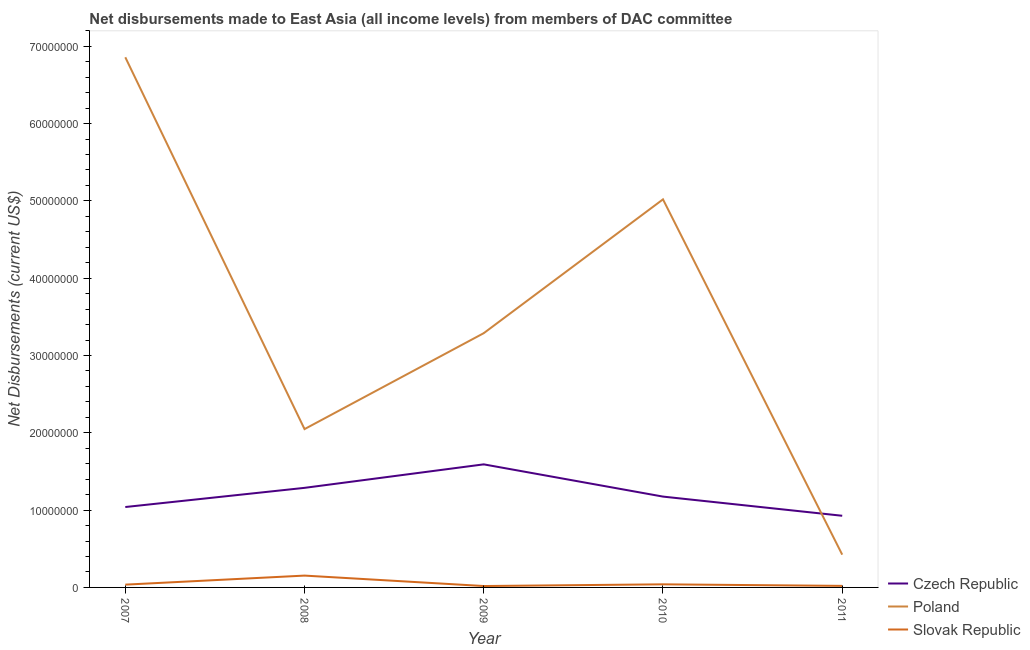How many different coloured lines are there?
Offer a very short reply. 3. Does the line corresponding to net disbursements made by slovak republic intersect with the line corresponding to net disbursements made by czech republic?
Offer a terse response. No. What is the net disbursements made by slovak republic in 2011?
Your response must be concise. 2.00e+05. Across all years, what is the maximum net disbursements made by poland?
Your response must be concise. 6.86e+07. Across all years, what is the minimum net disbursements made by czech republic?
Offer a terse response. 9.27e+06. In which year was the net disbursements made by poland minimum?
Provide a succinct answer. 2011. What is the total net disbursements made by czech republic in the graph?
Your answer should be very brief. 6.02e+07. What is the difference between the net disbursements made by slovak republic in 2007 and that in 2011?
Give a very brief answer. 1.60e+05. What is the difference between the net disbursements made by czech republic in 2007 and the net disbursements made by slovak republic in 2008?
Give a very brief answer. 8.87e+06. What is the average net disbursements made by slovak republic per year?
Provide a succinct answer. 5.34e+05. In the year 2010, what is the difference between the net disbursements made by czech republic and net disbursements made by poland?
Offer a terse response. -3.84e+07. In how many years, is the net disbursements made by poland greater than 66000000 US$?
Offer a very short reply. 1. What is the ratio of the net disbursements made by czech republic in 2007 to that in 2011?
Provide a short and direct response. 1.12. Is the difference between the net disbursements made by poland in 2007 and 2011 greater than the difference between the net disbursements made by slovak republic in 2007 and 2011?
Offer a very short reply. Yes. What is the difference between the highest and the second highest net disbursements made by slovak republic?
Offer a very short reply. 1.13e+06. What is the difference between the highest and the lowest net disbursements made by czech republic?
Offer a terse response. 6.65e+06. In how many years, is the net disbursements made by czech republic greater than the average net disbursements made by czech republic taken over all years?
Your response must be concise. 2. Is the sum of the net disbursements made by czech republic in 2007 and 2011 greater than the maximum net disbursements made by slovak republic across all years?
Provide a succinct answer. Yes. Is it the case that in every year, the sum of the net disbursements made by czech republic and net disbursements made by poland is greater than the net disbursements made by slovak republic?
Provide a short and direct response. Yes. Does the net disbursements made by slovak republic monotonically increase over the years?
Your response must be concise. No. Is the net disbursements made by poland strictly greater than the net disbursements made by slovak republic over the years?
Offer a very short reply. Yes. What is the difference between two consecutive major ticks on the Y-axis?
Give a very brief answer. 1.00e+07. Does the graph contain any zero values?
Ensure brevity in your answer.  No. Does the graph contain grids?
Offer a terse response. No. How many legend labels are there?
Your answer should be very brief. 3. What is the title of the graph?
Make the answer very short. Net disbursements made to East Asia (all income levels) from members of DAC committee. Does "Wage workers" appear as one of the legend labels in the graph?
Offer a terse response. No. What is the label or title of the Y-axis?
Keep it short and to the point. Net Disbursements (current US$). What is the Net Disbursements (current US$) of Czech Republic in 2007?
Keep it short and to the point. 1.04e+07. What is the Net Disbursements (current US$) in Poland in 2007?
Give a very brief answer. 6.86e+07. What is the Net Disbursements (current US$) of Czech Republic in 2008?
Your answer should be compact. 1.29e+07. What is the Net Disbursements (current US$) of Poland in 2008?
Provide a short and direct response. 2.05e+07. What is the Net Disbursements (current US$) in Slovak Republic in 2008?
Ensure brevity in your answer.  1.53e+06. What is the Net Disbursements (current US$) in Czech Republic in 2009?
Offer a very short reply. 1.59e+07. What is the Net Disbursements (current US$) in Poland in 2009?
Give a very brief answer. 3.29e+07. What is the Net Disbursements (current US$) in Czech Republic in 2010?
Ensure brevity in your answer.  1.18e+07. What is the Net Disbursements (current US$) in Poland in 2010?
Offer a very short reply. 5.02e+07. What is the Net Disbursements (current US$) in Slovak Republic in 2010?
Provide a short and direct response. 4.00e+05. What is the Net Disbursements (current US$) in Czech Republic in 2011?
Offer a terse response. 9.27e+06. What is the Net Disbursements (current US$) in Poland in 2011?
Keep it short and to the point. 4.24e+06. What is the Net Disbursements (current US$) in Slovak Republic in 2011?
Your response must be concise. 2.00e+05. Across all years, what is the maximum Net Disbursements (current US$) of Czech Republic?
Offer a terse response. 1.59e+07. Across all years, what is the maximum Net Disbursements (current US$) of Poland?
Ensure brevity in your answer.  6.86e+07. Across all years, what is the maximum Net Disbursements (current US$) of Slovak Republic?
Give a very brief answer. 1.53e+06. Across all years, what is the minimum Net Disbursements (current US$) of Czech Republic?
Give a very brief answer. 9.27e+06. Across all years, what is the minimum Net Disbursements (current US$) in Poland?
Your answer should be very brief. 4.24e+06. What is the total Net Disbursements (current US$) in Czech Republic in the graph?
Your response must be concise. 6.02e+07. What is the total Net Disbursements (current US$) in Poland in the graph?
Your answer should be very brief. 1.76e+08. What is the total Net Disbursements (current US$) of Slovak Republic in the graph?
Ensure brevity in your answer.  2.67e+06. What is the difference between the Net Disbursements (current US$) of Czech Republic in 2007 and that in 2008?
Offer a very short reply. -2.48e+06. What is the difference between the Net Disbursements (current US$) in Poland in 2007 and that in 2008?
Keep it short and to the point. 4.81e+07. What is the difference between the Net Disbursements (current US$) in Slovak Republic in 2007 and that in 2008?
Your answer should be compact. -1.17e+06. What is the difference between the Net Disbursements (current US$) in Czech Republic in 2007 and that in 2009?
Give a very brief answer. -5.52e+06. What is the difference between the Net Disbursements (current US$) in Poland in 2007 and that in 2009?
Make the answer very short. 3.57e+07. What is the difference between the Net Disbursements (current US$) in Czech Republic in 2007 and that in 2010?
Keep it short and to the point. -1.35e+06. What is the difference between the Net Disbursements (current US$) in Poland in 2007 and that in 2010?
Offer a very short reply. 1.84e+07. What is the difference between the Net Disbursements (current US$) of Czech Republic in 2007 and that in 2011?
Your answer should be very brief. 1.13e+06. What is the difference between the Net Disbursements (current US$) of Poland in 2007 and that in 2011?
Ensure brevity in your answer.  6.43e+07. What is the difference between the Net Disbursements (current US$) of Slovak Republic in 2007 and that in 2011?
Give a very brief answer. 1.60e+05. What is the difference between the Net Disbursements (current US$) of Czech Republic in 2008 and that in 2009?
Make the answer very short. -3.04e+06. What is the difference between the Net Disbursements (current US$) in Poland in 2008 and that in 2009?
Make the answer very short. -1.24e+07. What is the difference between the Net Disbursements (current US$) of Slovak Republic in 2008 and that in 2009?
Your answer should be compact. 1.35e+06. What is the difference between the Net Disbursements (current US$) of Czech Republic in 2008 and that in 2010?
Give a very brief answer. 1.13e+06. What is the difference between the Net Disbursements (current US$) in Poland in 2008 and that in 2010?
Your answer should be very brief. -2.97e+07. What is the difference between the Net Disbursements (current US$) in Slovak Republic in 2008 and that in 2010?
Make the answer very short. 1.13e+06. What is the difference between the Net Disbursements (current US$) of Czech Republic in 2008 and that in 2011?
Make the answer very short. 3.61e+06. What is the difference between the Net Disbursements (current US$) in Poland in 2008 and that in 2011?
Make the answer very short. 1.62e+07. What is the difference between the Net Disbursements (current US$) in Slovak Republic in 2008 and that in 2011?
Keep it short and to the point. 1.33e+06. What is the difference between the Net Disbursements (current US$) of Czech Republic in 2009 and that in 2010?
Keep it short and to the point. 4.17e+06. What is the difference between the Net Disbursements (current US$) in Poland in 2009 and that in 2010?
Give a very brief answer. -1.73e+07. What is the difference between the Net Disbursements (current US$) in Slovak Republic in 2009 and that in 2010?
Your response must be concise. -2.20e+05. What is the difference between the Net Disbursements (current US$) of Czech Republic in 2009 and that in 2011?
Your answer should be very brief. 6.65e+06. What is the difference between the Net Disbursements (current US$) of Poland in 2009 and that in 2011?
Give a very brief answer. 2.86e+07. What is the difference between the Net Disbursements (current US$) in Slovak Republic in 2009 and that in 2011?
Ensure brevity in your answer.  -2.00e+04. What is the difference between the Net Disbursements (current US$) of Czech Republic in 2010 and that in 2011?
Ensure brevity in your answer.  2.48e+06. What is the difference between the Net Disbursements (current US$) in Poland in 2010 and that in 2011?
Give a very brief answer. 4.60e+07. What is the difference between the Net Disbursements (current US$) of Czech Republic in 2007 and the Net Disbursements (current US$) of Poland in 2008?
Give a very brief answer. -1.01e+07. What is the difference between the Net Disbursements (current US$) in Czech Republic in 2007 and the Net Disbursements (current US$) in Slovak Republic in 2008?
Your answer should be very brief. 8.87e+06. What is the difference between the Net Disbursements (current US$) of Poland in 2007 and the Net Disbursements (current US$) of Slovak Republic in 2008?
Your response must be concise. 6.70e+07. What is the difference between the Net Disbursements (current US$) in Czech Republic in 2007 and the Net Disbursements (current US$) in Poland in 2009?
Offer a very short reply. -2.25e+07. What is the difference between the Net Disbursements (current US$) in Czech Republic in 2007 and the Net Disbursements (current US$) in Slovak Republic in 2009?
Your answer should be compact. 1.02e+07. What is the difference between the Net Disbursements (current US$) in Poland in 2007 and the Net Disbursements (current US$) in Slovak Republic in 2009?
Your answer should be very brief. 6.84e+07. What is the difference between the Net Disbursements (current US$) in Czech Republic in 2007 and the Net Disbursements (current US$) in Poland in 2010?
Make the answer very short. -3.98e+07. What is the difference between the Net Disbursements (current US$) in Poland in 2007 and the Net Disbursements (current US$) in Slovak Republic in 2010?
Keep it short and to the point. 6.82e+07. What is the difference between the Net Disbursements (current US$) in Czech Republic in 2007 and the Net Disbursements (current US$) in Poland in 2011?
Give a very brief answer. 6.16e+06. What is the difference between the Net Disbursements (current US$) in Czech Republic in 2007 and the Net Disbursements (current US$) in Slovak Republic in 2011?
Your answer should be very brief. 1.02e+07. What is the difference between the Net Disbursements (current US$) of Poland in 2007 and the Net Disbursements (current US$) of Slovak Republic in 2011?
Make the answer very short. 6.84e+07. What is the difference between the Net Disbursements (current US$) of Czech Republic in 2008 and the Net Disbursements (current US$) of Poland in 2009?
Provide a short and direct response. -2.00e+07. What is the difference between the Net Disbursements (current US$) of Czech Republic in 2008 and the Net Disbursements (current US$) of Slovak Republic in 2009?
Offer a very short reply. 1.27e+07. What is the difference between the Net Disbursements (current US$) of Poland in 2008 and the Net Disbursements (current US$) of Slovak Republic in 2009?
Your answer should be compact. 2.03e+07. What is the difference between the Net Disbursements (current US$) of Czech Republic in 2008 and the Net Disbursements (current US$) of Poland in 2010?
Keep it short and to the point. -3.73e+07. What is the difference between the Net Disbursements (current US$) of Czech Republic in 2008 and the Net Disbursements (current US$) of Slovak Republic in 2010?
Ensure brevity in your answer.  1.25e+07. What is the difference between the Net Disbursements (current US$) of Poland in 2008 and the Net Disbursements (current US$) of Slovak Republic in 2010?
Your response must be concise. 2.01e+07. What is the difference between the Net Disbursements (current US$) of Czech Republic in 2008 and the Net Disbursements (current US$) of Poland in 2011?
Your answer should be very brief. 8.64e+06. What is the difference between the Net Disbursements (current US$) of Czech Republic in 2008 and the Net Disbursements (current US$) of Slovak Republic in 2011?
Your answer should be compact. 1.27e+07. What is the difference between the Net Disbursements (current US$) of Poland in 2008 and the Net Disbursements (current US$) of Slovak Republic in 2011?
Offer a very short reply. 2.03e+07. What is the difference between the Net Disbursements (current US$) of Czech Republic in 2009 and the Net Disbursements (current US$) of Poland in 2010?
Keep it short and to the point. -3.43e+07. What is the difference between the Net Disbursements (current US$) in Czech Republic in 2009 and the Net Disbursements (current US$) in Slovak Republic in 2010?
Your response must be concise. 1.55e+07. What is the difference between the Net Disbursements (current US$) in Poland in 2009 and the Net Disbursements (current US$) in Slovak Republic in 2010?
Your answer should be compact. 3.25e+07. What is the difference between the Net Disbursements (current US$) in Czech Republic in 2009 and the Net Disbursements (current US$) in Poland in 2011?
Keep it short and to the point. 1.17e+07. What is the difference between the Net Disbursements (current US$) in Czech Republic in 2009 and the Net Disbursements (current US$) in Slovak Republic in 2011?
Your answer should be compact. 1.57e+07. What is the difference between the Net Disbursements (current US$) of Poland in 2009 and the Net Disbursements (current US$) of Slovak Republic in 2011?
Your response must be concise. 3.27e+07. What is the difference between the Net Disbursements (current US$) of Czech Republic in 2010 and the Net Disbursements (current US$) of Poland in 2011?
Offer a very short reply. 7.51e+06. What is the difference between the Net Disbursements (current US$) in Czech Republic in 2010 and the Net Disbursements (current US$) in Slovak Republic in 2011?
Your answer should be compact. 1.16e+07. What is the average Net Disbursements (current US$) in Czech Republic per year?
Your answer should be very brief. 1.20e+07. What is the average Net Disbursements (current US$) in Poland per year?
Your answer should be very brief. 3.53e+07. What is the average Net Disbursements (current US$) of Slovak Republic per year?
Offer a terse response. 5.34e+05. In the year 2007, what is the difference between the Net Disbursements (current US$) in Czech Republic and Net Disbursements (current US$) in Poland?
Your answer should be very brief. -5.82e+07. In the year 2007, what is the difference between the Net Disbursements (current US$) in Czech Republic and Net Disbursements (current US$) in Slovak Republic?
Keep it short and to the point. 1.00e+07. In the year 2007, what is the difference between the Net Disbursements (current US$) in Poland and Net Disbursements (current US$) in Slovak Republic?
Make the answer very short. 6.82e+07. In the year 2008, what is the difference between the Net Disbursements (current US$) in Czech Republic and Net Disbursements (current US$) in Poland?
Offer a terse response. -7.60e+06. In the year 2008, what is the difference between the Net Disbursements (current US$) in Czech Republic and Net Disbursements (current US$) in Slovak Republic?
Give a very brief answer. 1.14e+07. In the year 2008, what is the difference between the Net Disbursements (current US$) of Poland and Net Disbursements (current US$) of Slovak Republic?
Provide a short and direct response. 1.90e+07. In the year 2009, what is the difference between the Net Disbursements (current US$) of Czech Republic and Net Disbursements (current US$) of Poland?
Make the answer very short. -1.70e+07. In the year 2009, what is the difference between the Net Disbursements (current US$) of Czech Republic and Net Disbursements (current US$) of Slovak Republic?
Your response must be concise. 1.57e+07. In the year 2009, what is the difference between the Net Disbursements (current US$) of Poland and Net Disbursements (current US$) of Slovak Republic?
Provide a succinct answer. 3.27e+07. In the year 2010, what is the difference between the Net Disbursements (current US$) in Czech Republic and Net Disbursements (current US$) in Poland?
Your answer should be very brief. -3.84e+07. In the year 2010, what is the difference between the Net Disbursements (current US$) of Czech Republic and Net Disbursements (current US$) of Slovak Republic?
Your answer should be very brief. 1.14e+07. In the year 2010, what is the difference between the Net Disbursements (current US$) in Poland and Net Disbursements (current US$) in Slovak Republic?
Your answer should be compact. 4.98e+07. In the year 2011, what is the difference between the Net Disbursements (current US$) of Czech Republic and Net Disbursements (current US$) of Poland?
Offer a terse response. 5.03e+06. In the year 2011, what is the difference between the Net Disbursements (current US$) of Czech Republic and Net Disbursements (current US$) of Slovak Republic?
Give a very brief answer. 9.07e+06. In the year 2011, what is the difference between the Net Disbursements (current US$) of Poland and Net Disbursements (current US$) of Slovak Republic?
Give a very brief answer. 4.04e+06. What is the ratio of the Net Disbursements (current US$) of Czech Republic in 2007 to that in 2008?
Make the answer very short. 0.81. What is the ratio of the Net Disbursements (current US$) of Poland in 2007 to that in 2008?
Keep it short and to the point. 3.35. What is the ratio of the Net Disbursements (current US$) of Slovak Republic in 2007 to that in 2008?
Give a very brief answer. 0.24. What is the ratio of the Net Disbursements (current US$) in Czech Republic in 2007 to that in 2009?
Give a very brief answer. 0.65. What is the ratio of the Net Disbursements (current US$) in Poland in 2007 to that in 2009?
Your response must be concise. 2.09. What is the ratio of the Net Disbursements (current US$) in Slovak Republic in 2007 to that in 2009?
Give a very brief answer. 2. What is the ratio of the Net Disbursements (current US$) in Czech Republic in 2007 to that in 2010?
Keep it short and to the point. 0.89. What is the ratio of the Net Disbursements (current US$) in Poland in 2007 to that in 2010?
Ensure brevity in your answer.  1.37. What is the ratio of the Net Disbursements (current US$) in Slovak Republic in 2007 to that in 2010?
Make the answer very short. 0.9. What is the ratio of the Net Disbursements (current US$) in Czech Republic in 2007 to that in 2011?
Offer a very short reply. 1.12. What is the ratio of the Net Disbursements (current US$) in Poland in 2007 to that in 2011?
Your answer should be compact. 16.17. What is the ratio of the Net Disbursements (current US$) in Czech Republic in 2008 to that in 2009?
Keep it short and to the point. 0.81. What is the ratio of the Net Disbursements (current US$) in Poland in 2008 to that in 2009?
Keep it short and to the point. 0.62. What is the ratio of the Net Disbursements (current US$) in Slovak Republic in 2008 to that in 2009?
Give a very brief answer. 8.5. What is the ratio of the Net Disbursements (current US$) in Czech Republic in 2008 to that in 2010?
Your answer should be very brief. 1.1. What is the ratio of the Net Disbursements (current US$) in Poland in 2008 to that in 2010?
Ensure brevity in your answer.  0.41. What is the ratio of the Net Disbursements (current US$) of Slovak Republic in 2008 to that in 2010?
Provide a short and direct response. 3.83. What is the ratio of the Net Disbursements (current US$) of Czech Republic in 2008 to that in 2011?
Your answer should be very brief. 1.39. What is the ratio of the Net Disbursements (current US$) in Poland in 2008 to that in 2011?
Give a very brief answer. 4.83. What is the ratio of the Net Disbursements (current US$) of Slovak Republic in 2008 to that in 2011?
Provide a succinct answer. 7.65. What is the ratio of the Net Disbursements (current US$) in Czech Republic in 2009 to that in 2010?
Make the answer very short. 1.35. What is the ratio of the Net Disbursements (current US$) in Poland in 2009 to that in 2010?
Your answer should be very brief. 0.66. What is the ratio of the Net Disbursements (current US$) in Slovak Republic in 2009 to that in 2010?
Offer a very short reply. 0.45. What is the ratio of the Net Disbursements (current US$) in Czech Republic in 2009 to that in 2011?
Provide a short and direct response. 1.72. What is the ratio of the Net Disbursements (current US$) in Poland in 2009 to that in 2011?
Offer a terse response. 7.76. What is the ratio of the Net Disbursements (current US$) in Czech Republic in 2010 to that in 2011?
Your answer should be very brief. 1.27. What is the ratio of the Net Disbursements (current US$) in Poland in 2010 to that in 2011?
Offer a very short reply. 11.84. What is the ratio of the Net Disbursements (current US$) in Slovak Republic in 2010 to that in 2011?
Your answer should be compact. 2. What is the difference between the highest and the second highest Net Disbursements (current US$) in Czech Republic?
Offer a very short reply. 3.04e+06. What is the difference between the highest and the second highest Net Disbursements (current US$) of Poland?
Your response must be concise. 1.84e+07. What is the difference between the highest and the second highest Net Disbursements (current US$) of Slovak Republic?
Provide a succinct answer. 1.13e+06. What is the difference between the highest and the lowest Net Disbursements (current US$) in Czech Republic?
Provide a short and direct response. 6.65e+06. What is the difference between the highest and the lowest Net Disbursements (current US$) of Poland?
Ensure brevity in your answer.  6.43e+07. What is the difference between the highest and the lowest Net Disbursements (current US$) of Slovak Republic?
Offer a very short reply. 1.35e+06. 